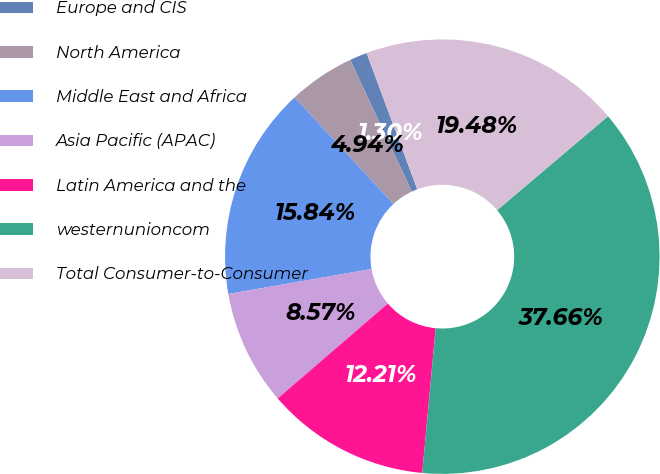Convert chart. <chart><loc_0><loc_0><loc_500><loc_500><pie_chart><fcel>Europe and CIS<fcel>North America<fcel>Middle East and Africa<fcel>Asia Pacific (APAC)<fcel>Latin America and the<fcel>westernunioncom<fcel>Total Consumer-to-Consumer<nl><fcel>1.3%<fcel>4.94%<fcel>15.84%<fcel>8.57%<fcel>12.21%<fcel>37.66%<fcel>19.48%<nl></chart> 